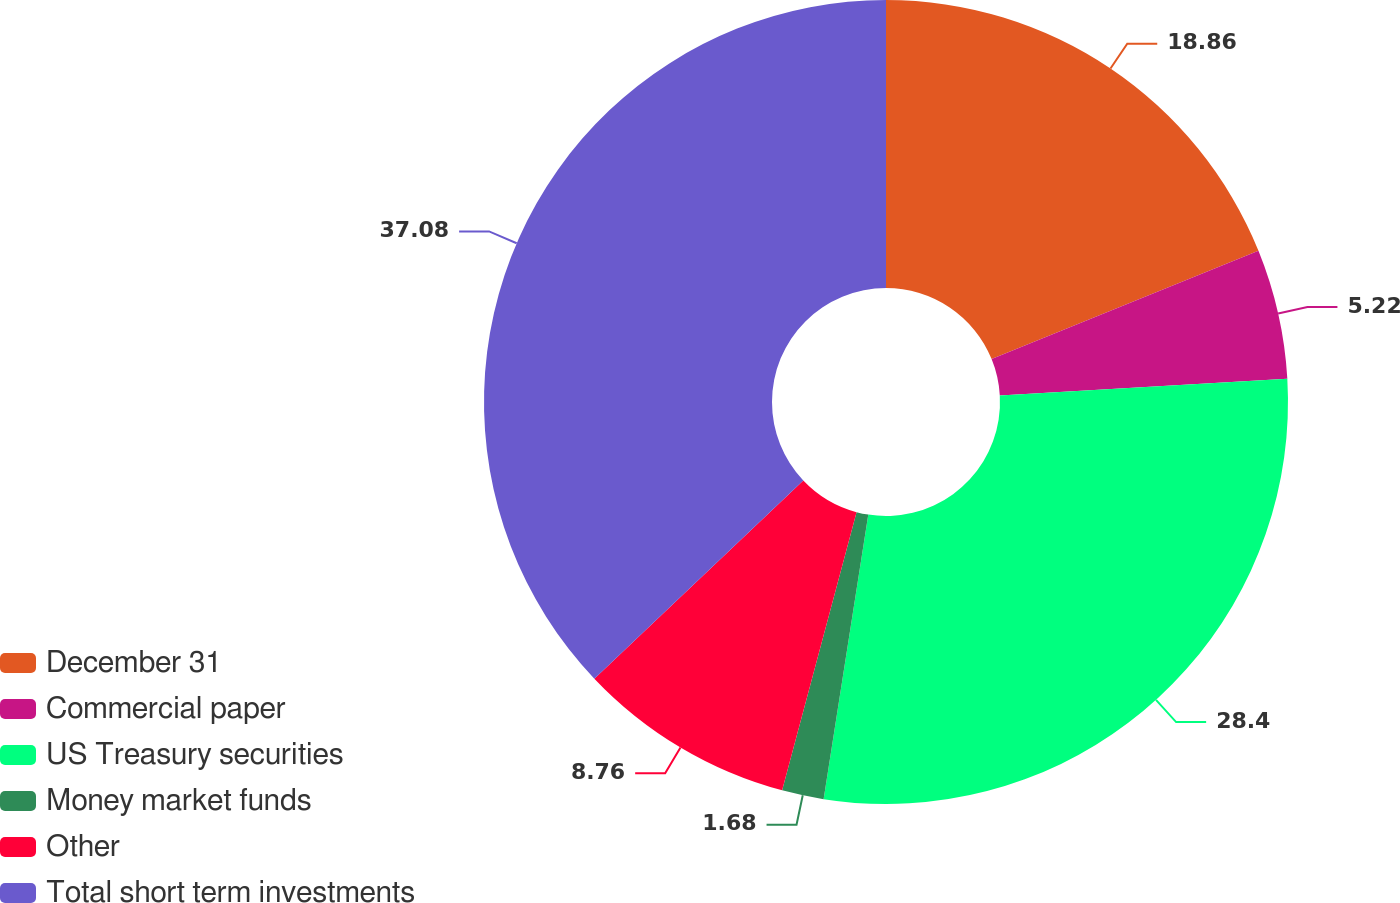Convert chart to OTSL. <chart><loc_0><loc_0><loc_500><loc_500><pie_chart><fcel>December 31<fcel>Commercial paper<fcel>US Treasury securities<fcel>Money market funds<fcel>Other<fcel>Total short term investments<nl><fcel>18.86%<fcel>5.22%<fcel>28.4%<fcel>1.68%<fcel>8.76%<fcel>37.08%<nl></chart> 